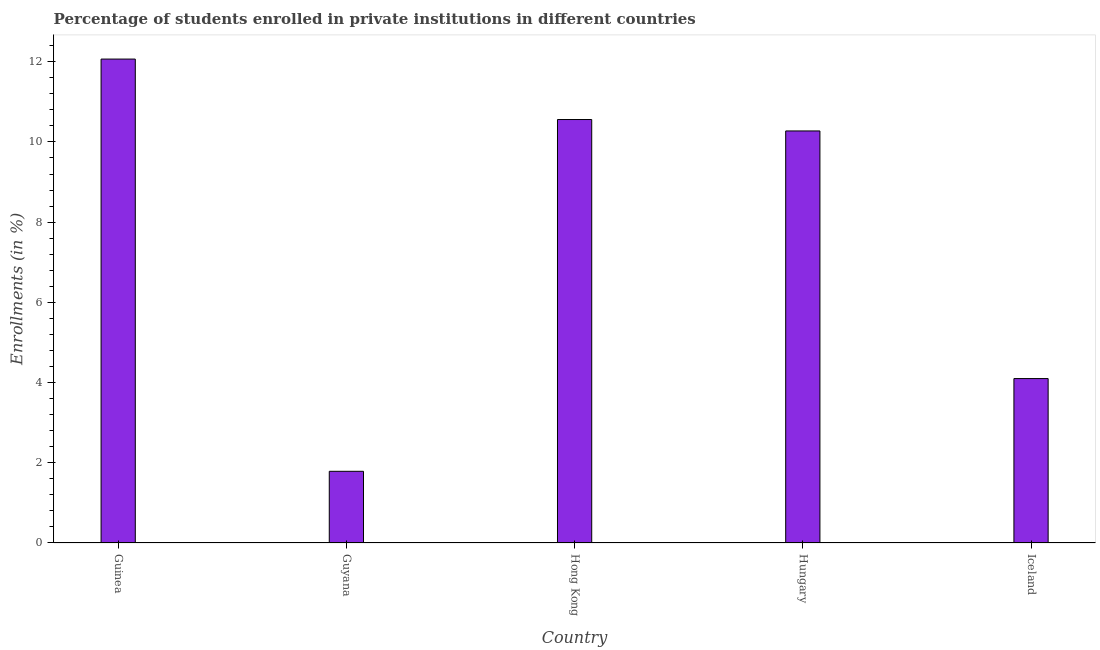Does the graph contain any zero values?
Offer a very short reply. No. What is the title of the graph?
Provide a succinct answer. Percentage of students enrolled in private institutions in different countries. What is the label or title of the X-axis?
Keep it short and to the point. Country. What is the label or title of the Y-axis?
Your response must be concise. Enrollments (in %). What is the enrollments in private institutions in Iceland?
Offer a terse response. 4.1. Across all countries, what is the maximum enrollments in private institutions?
Ensure brevity in your answer.  12.07. Across all countries, what is the minimum enrollments in private institutions?
Your response must be concise. 1.79. In which country was the enrollments in private institutions maximum?
Ensure brevity in your answer.  Guinea. In which country was the enrollments in private institutions minimum?
Offer a terse response. Guyana. What is the sum of the enrollments in private institutions?
Offer a terse response. 38.79. What is the difference between the enrollments in private institutions in Guyana and Hong Kong?
Your response must be concise. -8.77. What is the average enrollments in private institutions per country?
Your answer should be compact. 7.76. What is the median enrollments in private institutions?
Your answer should be compact. 10.27. What is the ratio of the enrollments in private institutions in Guyana to that in Iceland?
Provide a short and direct response. 0.44. Is the enrollments in private institutions in Guinea less than that in Guyana?
Offer a terse response. No. What is the difference between the highest and the second highest enrollments in private institutions?
Offer a terse response. 1.51. What is the difference between the highest and the lowest enrollments in private institutions?
Offer a terse response. 10.28. In how many countries, is the enrollments in private institutions greater than the average enrollments in private institutions taken over all countries?
Keep it short and to the point. 3. Are all the bars in the graph horizontal?
Make the answer very short. No. What is the difference between two consecutive major ticks on the Y-axis?
Give a very brief answer. 2. Are the values on the major ticks of Y-axis written in scientific E-notation?
Provide a succinct answer. No. What is the Enrollments (in %) in Guinea?
Ensure brevity in your answer.  12.07. What is the Enrollments (in %) in Guyana?
Your answer should be compact. 1.79. What is the Enrollments (in %) in Hong Kong?
Your answer should be compact. 10.56. What is the Enrollments (in %) in Hungary?
Make the answer very short. 10.27. What is the Enrollments (in %) in Iceland?
Keep it short and to the point. 4.1. What is the difference between the Enrollments (in %) in Guinea and Guyana?
Offer a terse response. 10.28. What is the difference between the Enrollments (in %) in Guinea and Hong Kong?
Offer a terse response. 1.51. What is the difference between the Enrollments (in %) in Guinea and Hungary?
Ensure brevity in your answer.  1.79. What is the difference between the Enrollments (in %) in Guinea and Iceland?
Provide a succinct answer. 7.97. What is the difference between the Enrollments (in %) in Guyana and Hong Kong?
Your response must be concise. -8.77. What is the difference between the Enrollments (in %) in Guyana and Hungary?
Your answer should be very brief. -8.49. What is the difference between the Enrollments (in %) in Guyana and Iceland?
Keep it short and to the point. -2.31. What is the difference between the Enrollments (in %) in Hong Kong and Hungary?
Offer a terse response. 0.28. What is the difference between the Enrollments (in %) in Hong Kong and Iceland?
Your answer should be very brief. 6.46. What is the difference between the Enrollments (in %) in Hungary and Iceland?
Make the answer very short. 6.17. What is the ratio of the Enrollments (in %) in Guinea to that in Guyana?
Provide a short and direct response. 6.75. What is the ratio of the Enrollments (in %) in Guinea to that in Hong Kong?
Keep it short and to the point. 1.14. What is the ratio of the Enrollments (in %) in Guinea to that in Hungary?
Offer a terse response. 1.17. What is the ratio of the Enrollments (in %) in Guinea to that in Iceland?
Your response must be concise. 2.94. What is the ratio of the Enrollments (in %) in Guyana to that in Hong Kong?
Give a very brief answer. 0.17. What is the ratio of the Enrollments (in %) in Guyana to that in Hungary?
Ensure brevity in your answer.  0.17. What is the ratio of the Enrollments (in %) in Guyana to that in Iceland?
Provide a succinct answer. 0.44. What is the ratio of the Enrollments (in %) in Hong Kong to that in Hungary?
Your response must be concise. 1.03. What is the ratio of the Enrollments (in %) in Hong Kong to that in Iceland?
Offer a terse response. 2.58. What is the ratio of the Enrollments (in %) in Hungary to that in Iceland?
Your response must be concise. 2.51. 